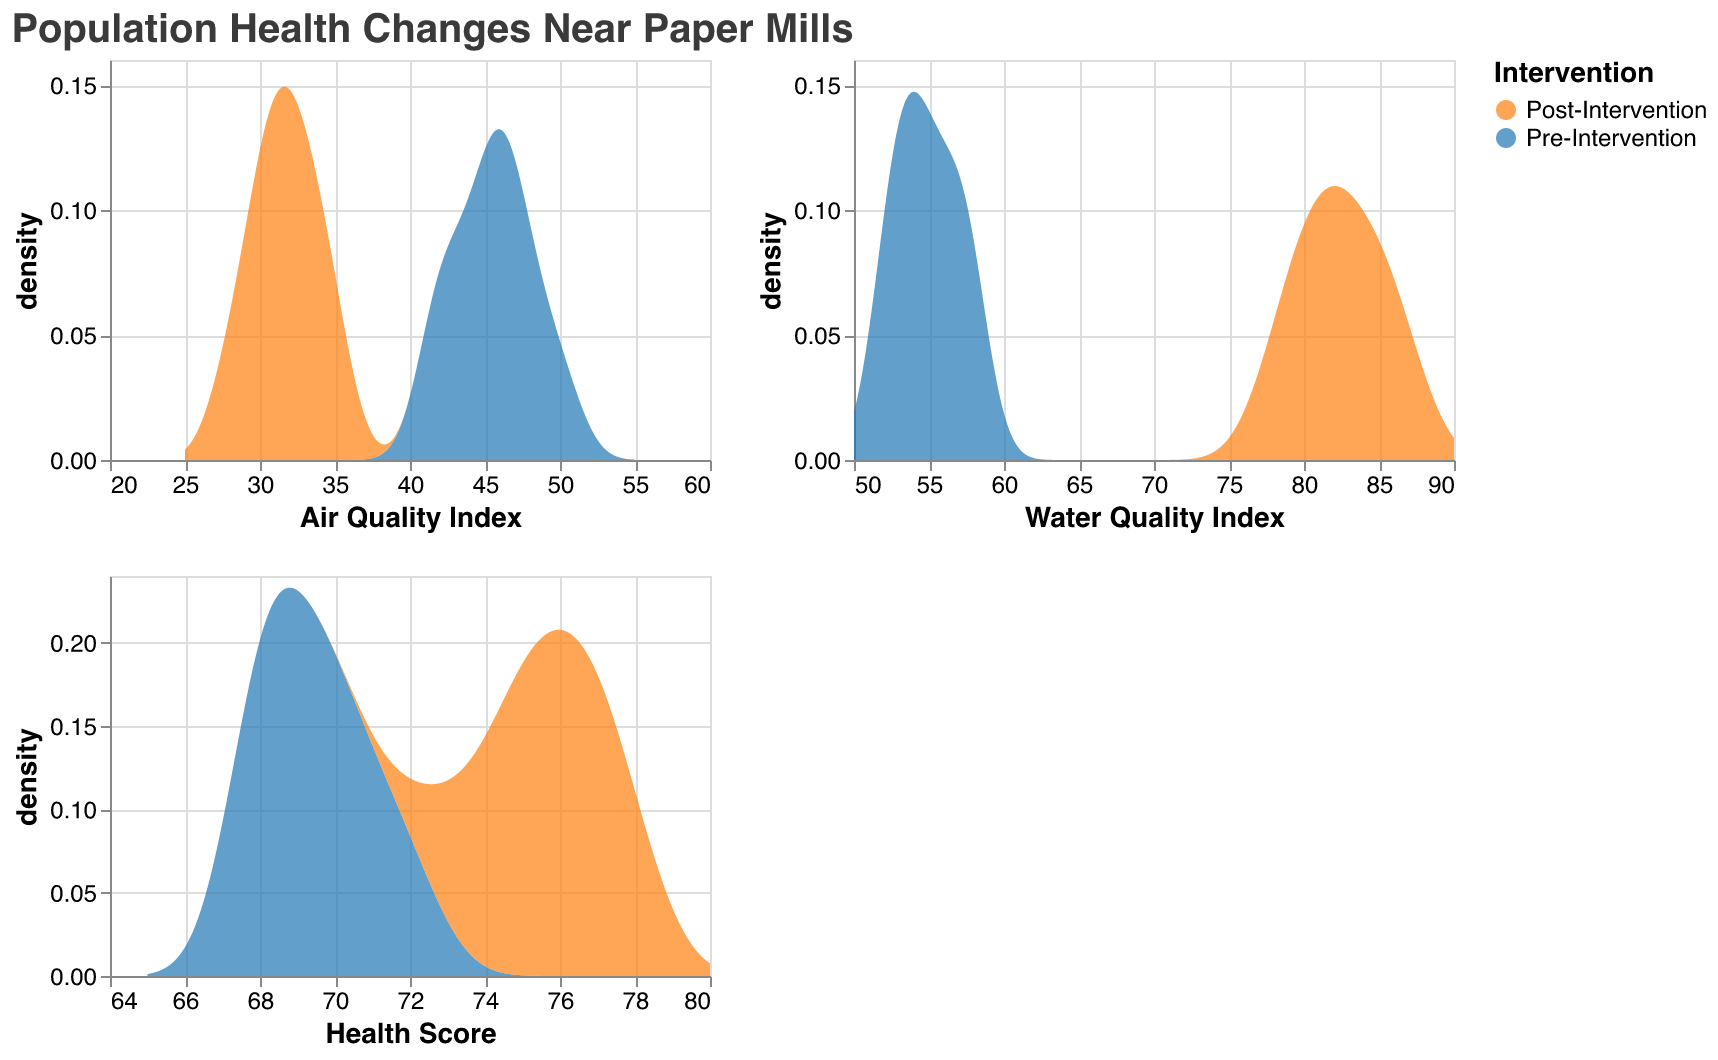What is the title of the figure? The title of the figure is usually located at the top and provides a summary of what the figure is about. Here it reads, "Population Health Changes Near Paper Mills".
Answer: Population Health Changes Near Paper Mills Which intervention group has a higher peak density for the Air Quality Index? By examining the density plot for the Air Quality Index, you can see that the Pre-Intervention group has a higher peak density compared to the Post-Intervention group. This is indicated by the higher density curve reaching its peak at a value greater than the Post-Intervention curve.
Answer: Pre-Intervention How does the Air Quality Index compare before and after intervention? To compare the Air Quality Index before and after the intervention, look at the overlapping density plots. The Pre-Intervention density is more spread out with higher values, while the Post-Intervention density is sharper and shifted towards lower Air Quality Index values, indicating an improvement in air quality post-intervention.
Answer: Air Quality Index improves after intervention What is the range of the Water Quality Index shown in the figure? The range of the Water Quality Index is visible on the x-axis of the second subplot. It extends from 50 to 90, as indicated by the axis title and tick marks.
Answer: 50 to 90 Which intervention group has a wider range in the Health Score? By examining the density plot of the Health Score, the Post-Intervention group shows a wider range as it covers values from about 70 to near 80 whereas the Pre-Intervention group mostly spans the lower part of the scale, indicating an improved and broader health score range post-intervention.
Answer: Post-Intervention In general, how do health scores change after intervention across all communities? To determine the general change in health scores after intervention, you can compare the density plots of the health scores pre- and post-intervention. The density plots post-intervention are shifted towards higher values, indicating improved health scores after the intervention.
Answer: Health scores generally improve Which group shows a sharper improvement in Water Quality Index after intervention? Compare the density plots for Water Quality Index. Post-Intervention groups show a notable peak towards the higher end (around 82-87), while Pre-Intervention groups have a lower peak within the range of 50-57. This indicates a significant improvement in water quality after intervention.
Answer: Post-Intervention What are the community names represented in the data? The community names are usually mentioned in the data description or can be inferred from the patterns in the density plots. Here they are "Jacksonville", "Duluth", and "Augusta".
Answer: Jacksonville, Duluth, Augusta 